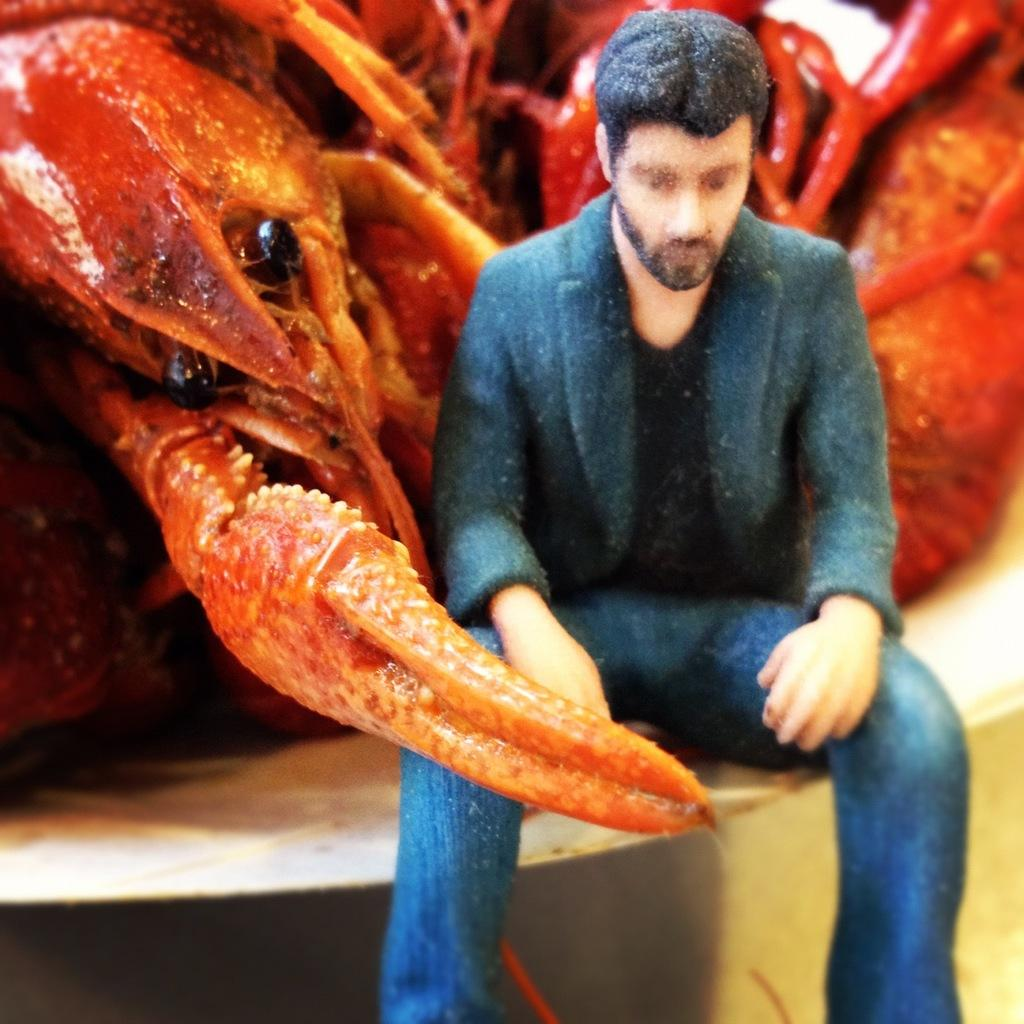What is the main subject of the image? There is a person sitting in the image. Can you describe the person's surroundings? There is a crab visible behind the person. What type of flame can be seen burning in the image? There is no flame present in the image; it only features a person sitting and a crab behind them. 